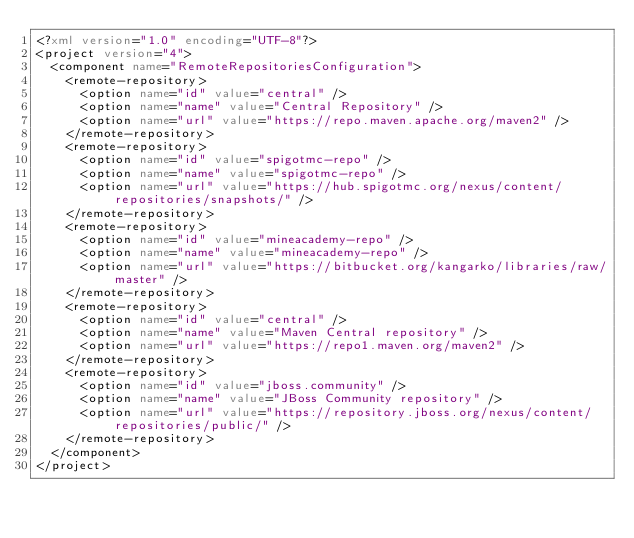Convert code to text. <code><loc_0><loc_0><loc_500><loc_500><_XML_><?xml version="1.0" encoding="UTF-8"?>
<project version="4">
  <component name="RemoteRepositoriesConfiguration">
    <remote-repository>
      <option name="id" value="central" />
      <option name="name" value="Central Repository" />
      <option name="url" value="https://repo.maven.apache.org/maven2" />
    </remote-repository>
    <remote-repository>
      <option name="id" value="spigotmc-repo" />
      <option name="name" value="spigotmc-repo" />
      <option name="url" value="https://hub.spigotmc.org/nexus/content/repositories/snapshots/" />
    </remote-repository>
    <remote-repository>
      <option name="id" value="mineacademy-repo" />
      <option name="name" value="mineacademy-repo" />
      <option name="url" value="https://bitbucket.org/kangarko/libraries/raw/master" />
    </remote-repository>
    <remote-repository>
      <option name="id" value="central" />
      <option name="name" value="Maven Central repository" />
      <option name="url" value="https://repo1.maven.org/maven2" />
    </remote-repository>
    <remote-repository>
      <option name="id" value="jboss.community" />
      <option name="name" value="JBoss Community repository" />
      <option name="url" value="https://repository.jboss.org/nexus/content/repositories/public/" />
    </remote-repository>
  </component>
</project></code> 